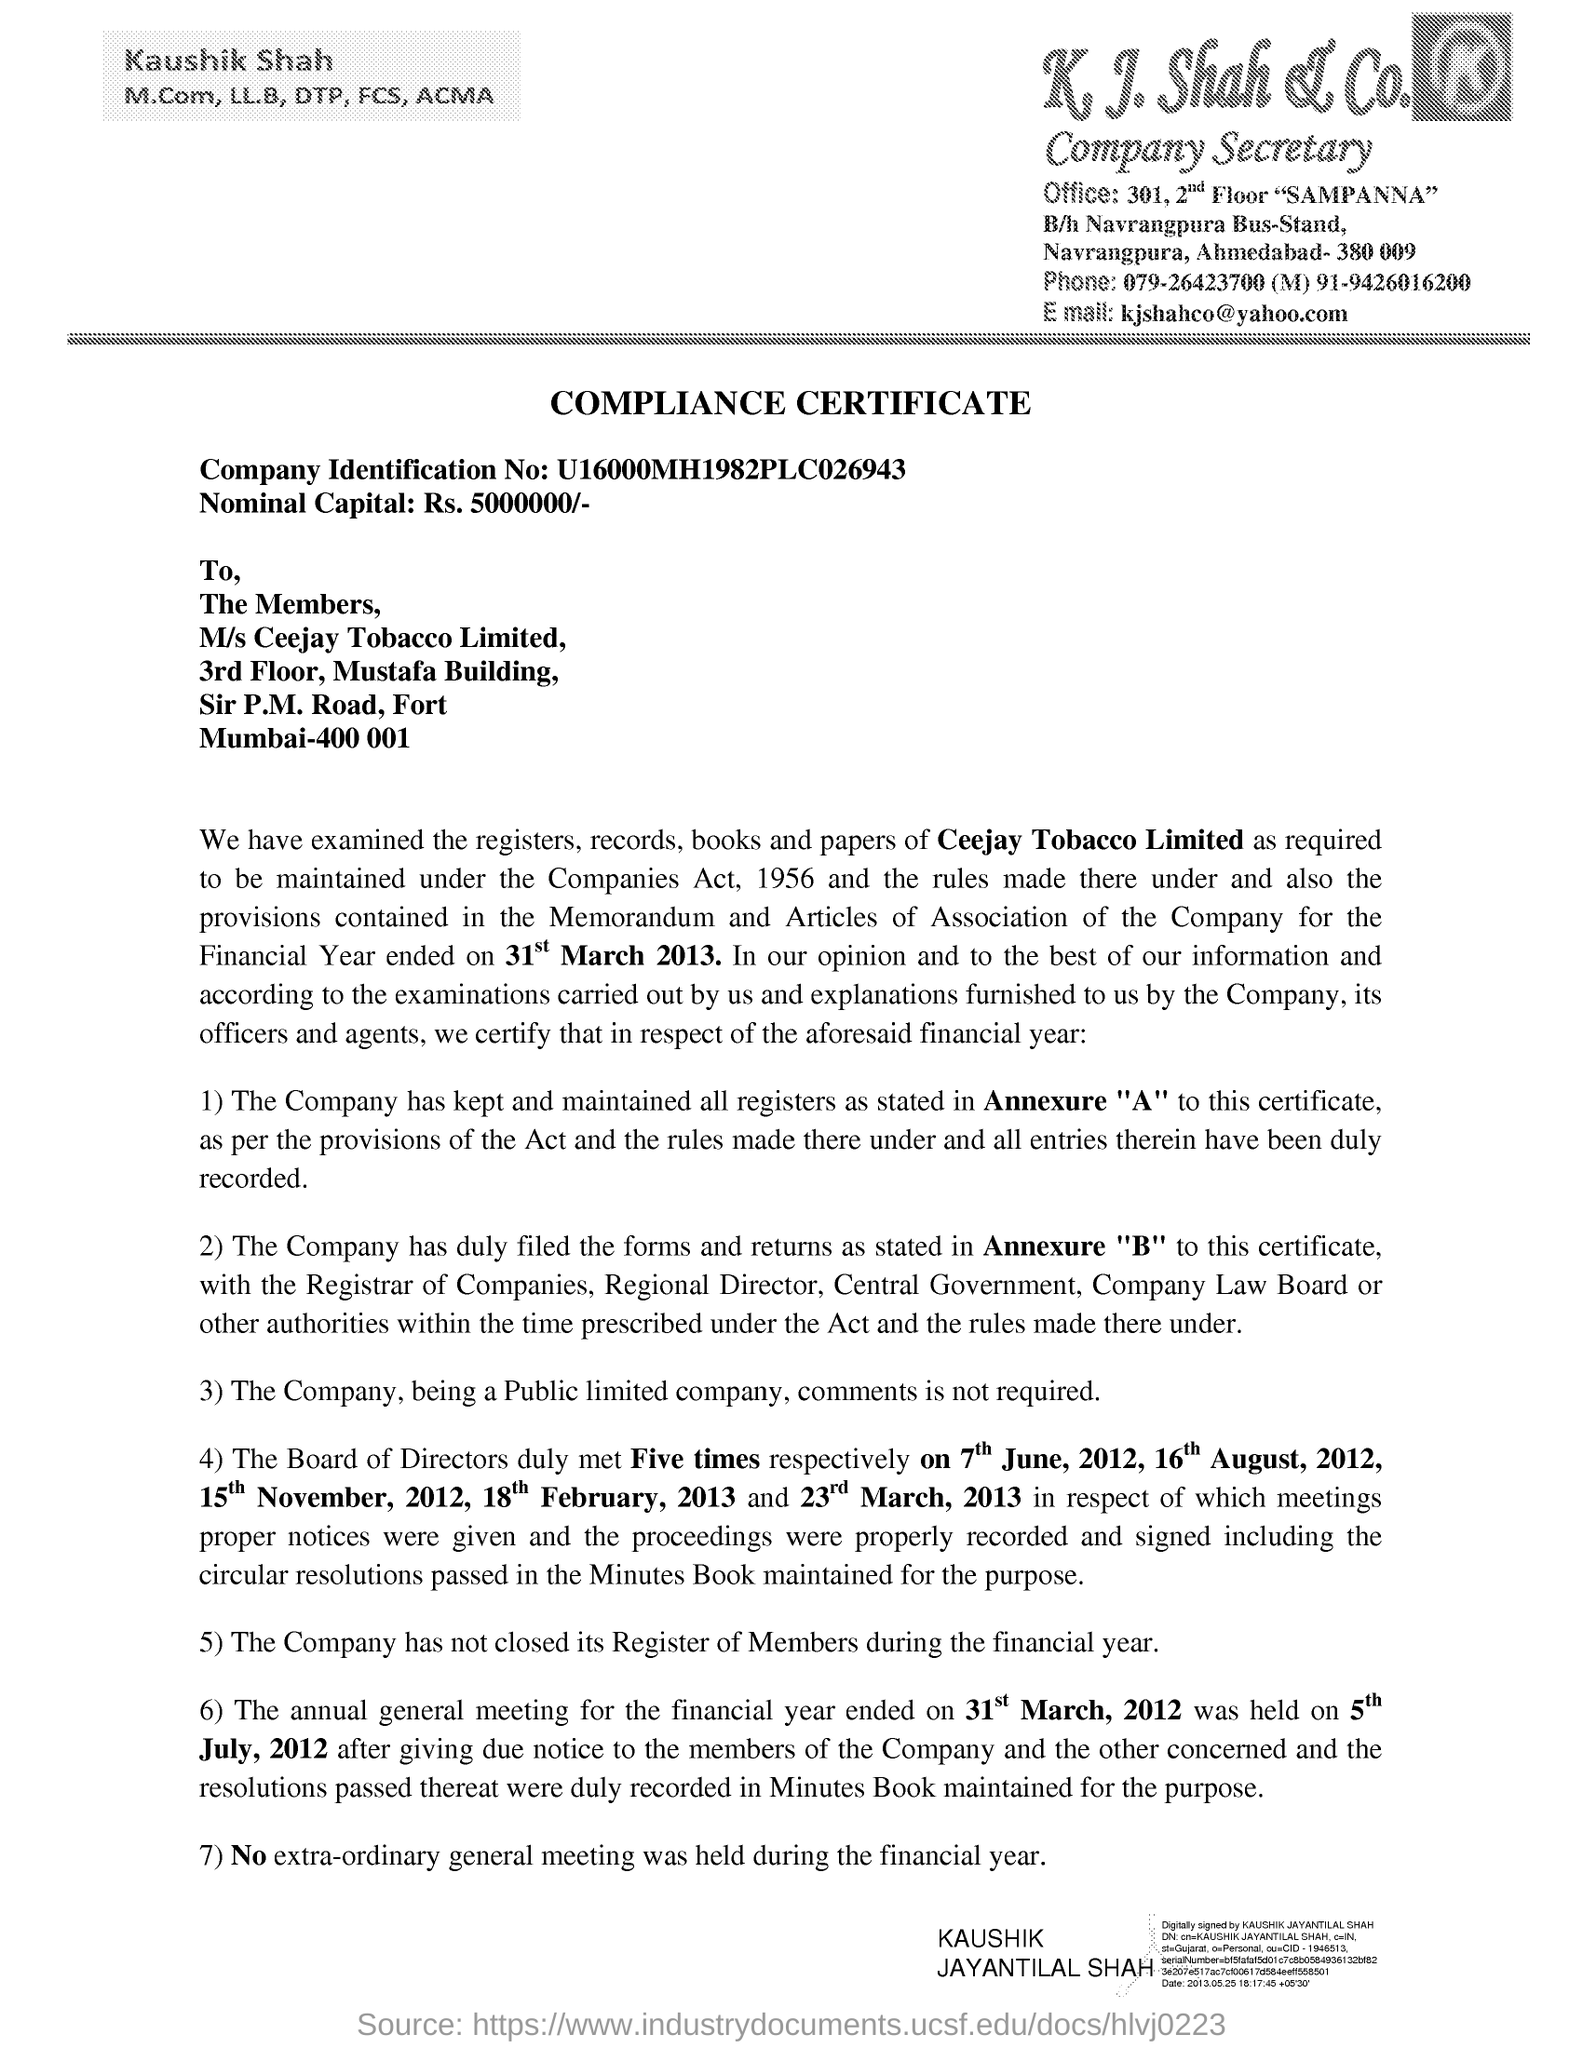Can you tell more about the financial year mentioned in the document? The document refers to the financial year ending on 31st March 2013. It discusses compliance with legal and regulatory requirements for that period, likely outlining the company's adherence to financial and corporate laws. What specific activities does the document say were completed during this period? The document notes that the Board of Directors met five times during the year, and the annual general meeting for the year was held on 5th July 2012. These meetings are essential for corporate governance, involving strategic decision-making and compliance reporting. 